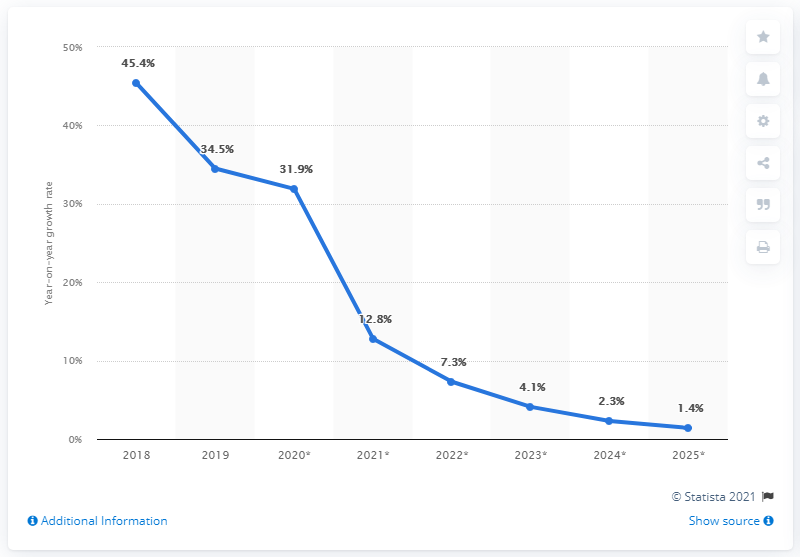Outline some significant characteristics in this image. In 2018, the line graph achieved its highest peak. As per the Digital Market Outlook, the retail e-commerce sales revenue in Mexico is projected to grow by 31.9% in 2019. The e-commerce sales growth over the years has shown a difference between the maximum and minimum values, with the maximum value being 0.44 and the minimum value being 0. 